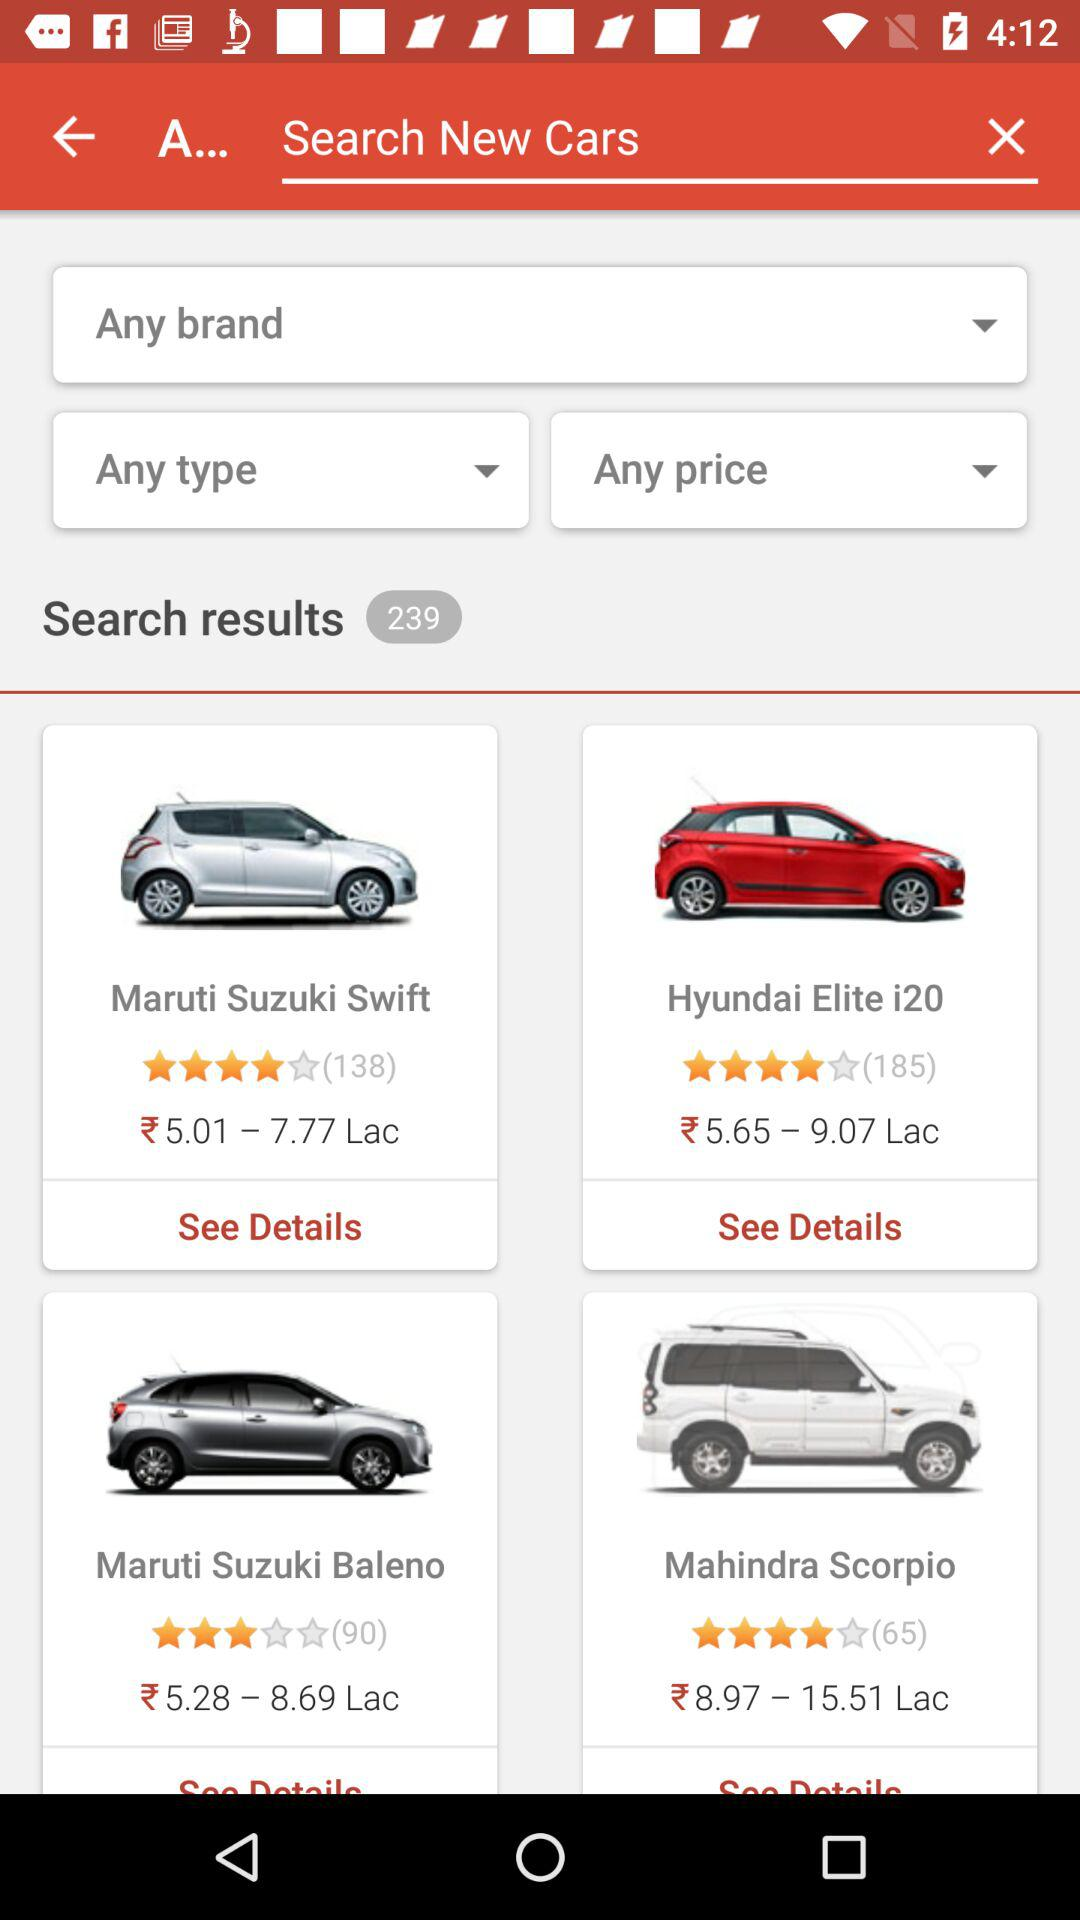How many search results are shown? There are 239 search results. 